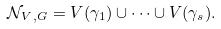<formula> <loc_0><loc_0><loc_500><loc_500>\mathcal { N } _ { V \, , G } = V ( \gamma _ { 1 } ) \cup \dots \cup V ( \gamma _ { s } ) .</formula> 